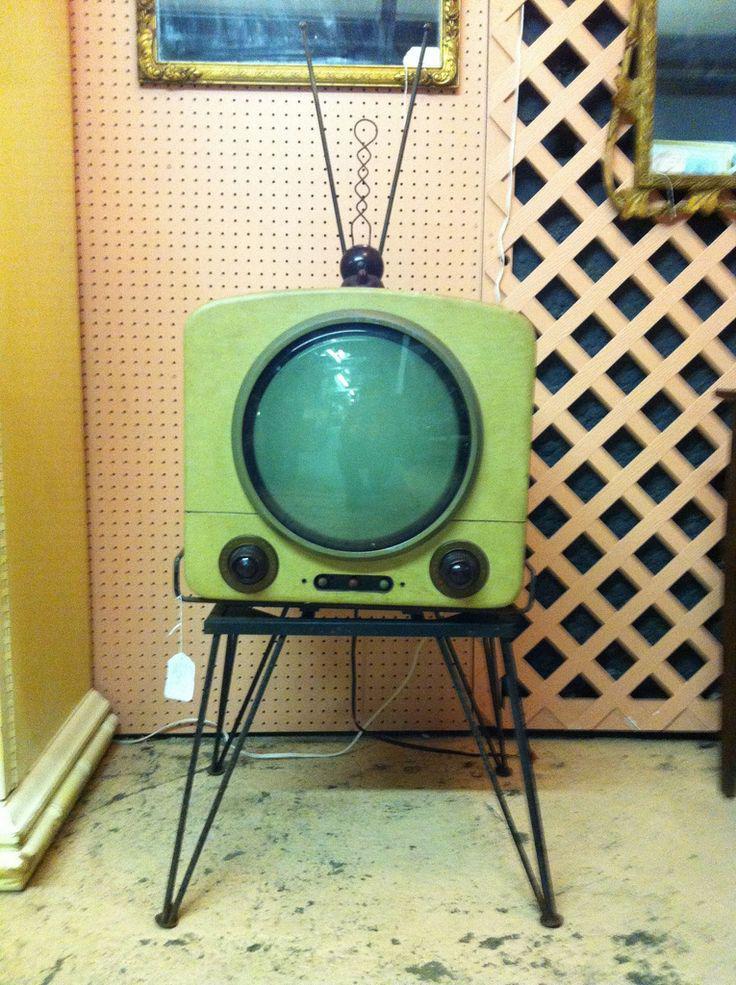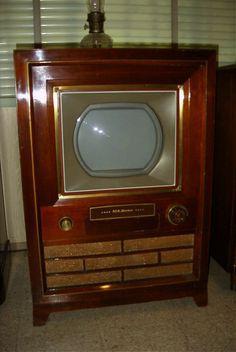The first image is the image on the left, the second image is the image on the right. For the images displayed, is the sentence "A pile of old television sits in a room with a wallpapered wall behind it." factually correct? Answer yes or no. No. The first image is the image on the left, the second image is the image on the right. For the images displayed, is the sentence "There is some kind of armed seat in a room containing a stack of old-fashioned TV sets." factually correct? Answer yes or no. No. 